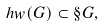<formula> <loc_0><loc_0><loc_500><loc_500>h w ( G ) \subset \S G ,</formula> 